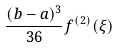Convert formula to latex. <formula><loc_0><loc_0><loc_500><loc_500>\frac { ( b - a ) ^ { 3 } } { 3 6 } f ^ { ( 2 ) } ( \xi )</formula> 